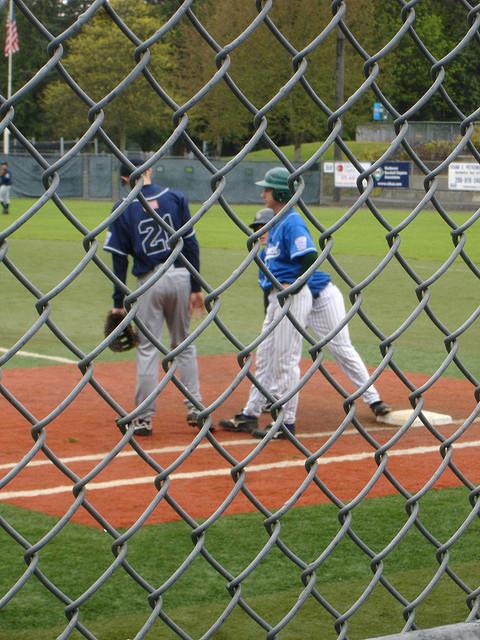Can you see the mountains?
Give a very brief answer. No. What type of fence is in the scene?
Be succinct. Metal. What number is on the child's back?
Keep it brief. 21. What position is the boy with the mitt playing?
Short answer required. First base. Is everyone in the picture wearing the same color pants?
Short answer required. No. Is the man wearing a long-sleeved shirt?
Keep it brief. Yes. Which base is the runner on?
Concise answer only. 1st. Does the team have uniforms?
Answer briefly. Yes. What is the man holding?
Give a very brief answer. Glove. 